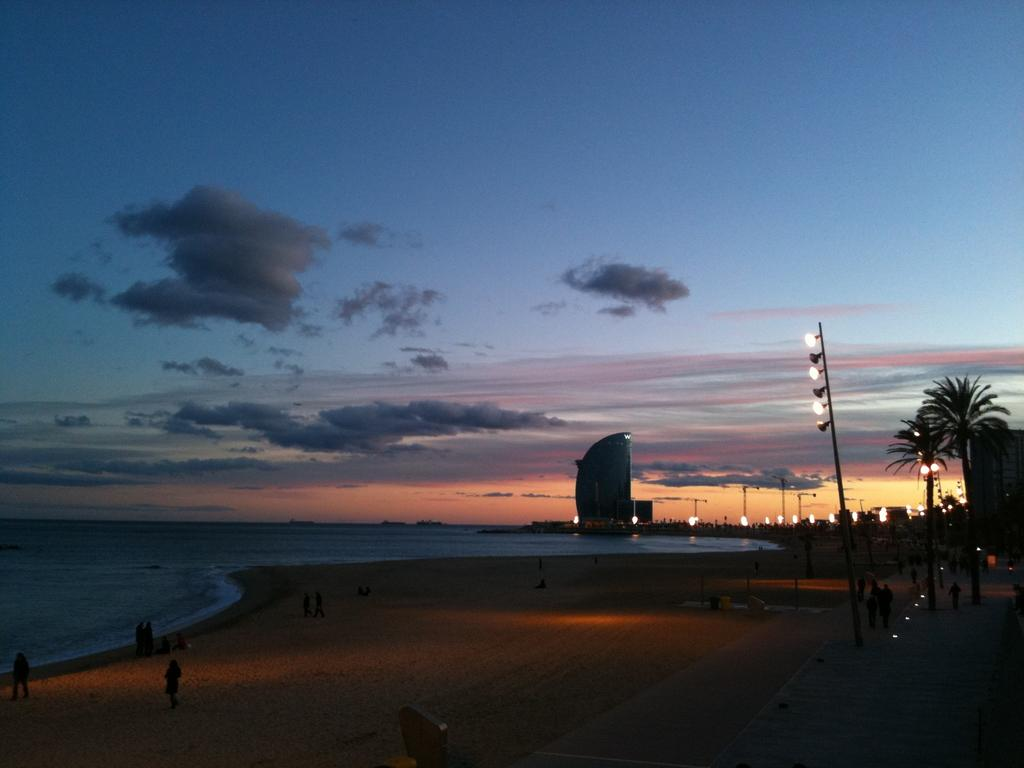What type of lighting is present in the image? There are pole lights in the image. What natural elements can be seen in the image? There are trees in the image. What man-made structures are visible in the image? There are buildings in the image. What are the people in the image doing? There are people standing on the ground in the image. What body of water is visible in the image? There is water visible in the image. What other objects can be found on the ground in the image? There are other objects on the ground in the image. What can be seen in the background of the image? The sky is visible in the background of the image. Can you see any ears in the image? There are no ears visible in the image. Is there a glass object present in the image? There is no glass object present in the image. 